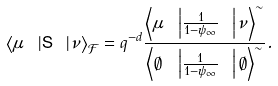Convert formula to latex. <formula><loc_0><loc_0><loc_500><loc_500>\left \langle \mu \ \left | { \mathsf S } \ \right | \nu \right \rangle _ { \mathcal { F } } = q ^ { - d } \frac { \left \langle \mu \ \left | \frac { 1 } { 1 - \psi _ { \infty } } \ \right | \nu \right \rangle ^ { \sim } } { \left \langle \emptyset \ \left | \frac { 1 } { 1 - \psi _ { \infty } } \ \right | \emptyset \right \rangle ^ { \sim } } .</formula> 